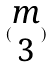Convert formula to latex. <formula><loc_0><loc_0><loc_500><loc_500>( \begin{matrix} m \\ 3 \end{matrix} )</formula> 